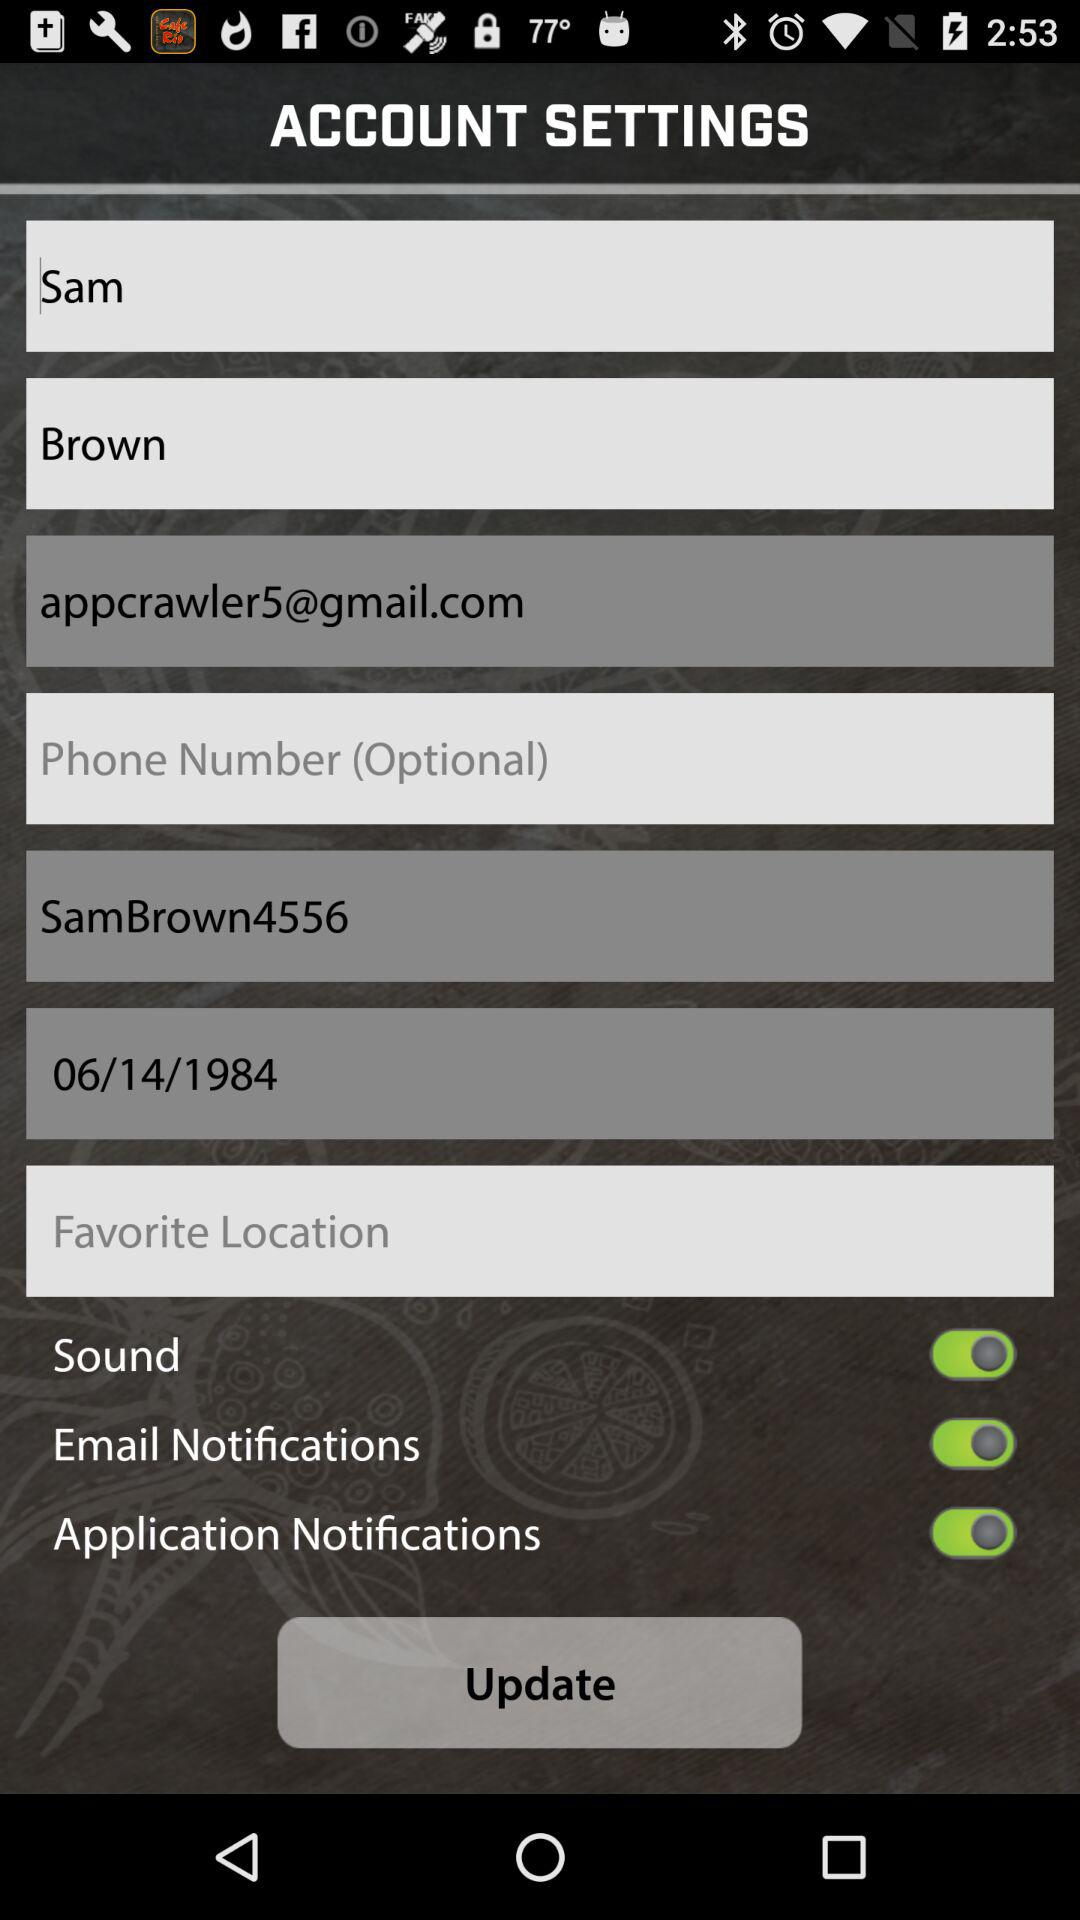What is the date of birth? The date of birth is June 14, 1984. 